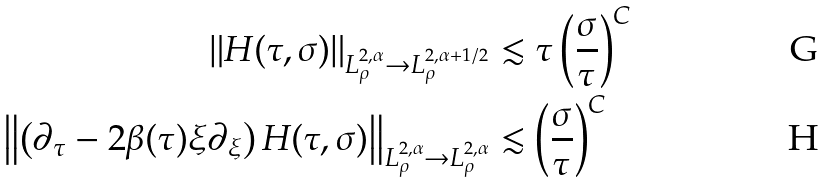Convert formula to latex. <formula><loc_0><loc_0><loc_500><loc_500>\| H ( \tau , \sigma ) \| _ { L ^ { 2 , \alpha } _ { \rho } \to L ^ { 2 , \alpha + 1 / 2 } _ { \rho } } & \lesssim \tau \left ( \frac { \sigma } { \tau } \right ) ^ { C } \\ \left \| \left ( \partial _ { \tau } - 2 \beta ( \tau ) \xi \partial _ { \xi } \right ) H ( \tau , \sigma ) \right \| _ { L ^ { 2 , \alpha } _ { \rho } \to L ^ { 2 , \alpha } _ { \rho } } & \lesssim \left ( \frac { \sigma } { \tau } \right ) ^ { C }</formula> 